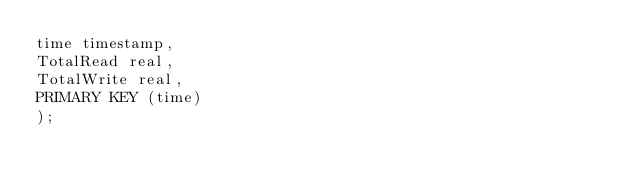Convert code to text. <code><loc_0><loc_0><loc_500><loc_500><_SQL_>time timestamp,
TotalRead real,
TotalWrite real,
PRIMARY KEY (time)
);
</code> 